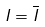Convert formula to latex. <formula><loc_0><loc_0><loc_500><loc_500>I = \overline { I }</formula> 